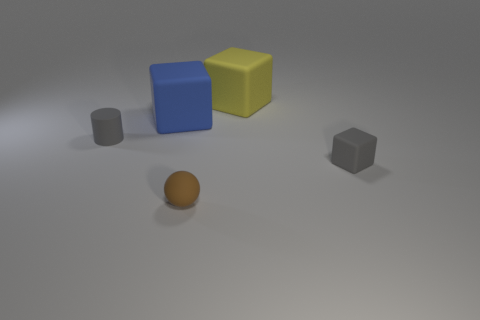Are there fewer tiny cylinders that are left of the small gray rubber cylinder than gray cubes?
Make the answer very short. Yes. There is a tiny object that is the same color as the small cube; what material is it?
Give a very brief answer. Rubber. Do the yellow cube and the tiny gray cylinder have the same material?
Your answer should be compact. Yes. How many yellow blocks are the same material as the large blue block?
Your answer should be compact. 1. There is a tiny cube that is made of the same material as the sphere; what color is it?
Provide a short and direct response. Gray. The brown thing is what shape?
Your response must be concise. Sphere. What is the big thing to the left of the small brown matte ball made of?
Offer a terse response. Rubber. Is there a block that has the same color as the tiny ball?
Provide a short and direct response. No. There is a blue thing that is the same size as the yellow rubber cube; what shape is it?
Offer a very short reply. Cube. What is the color of the large rubber object that is on the right side of the tiny brown matte ball?
Keep it short and to the point. Yellow. 